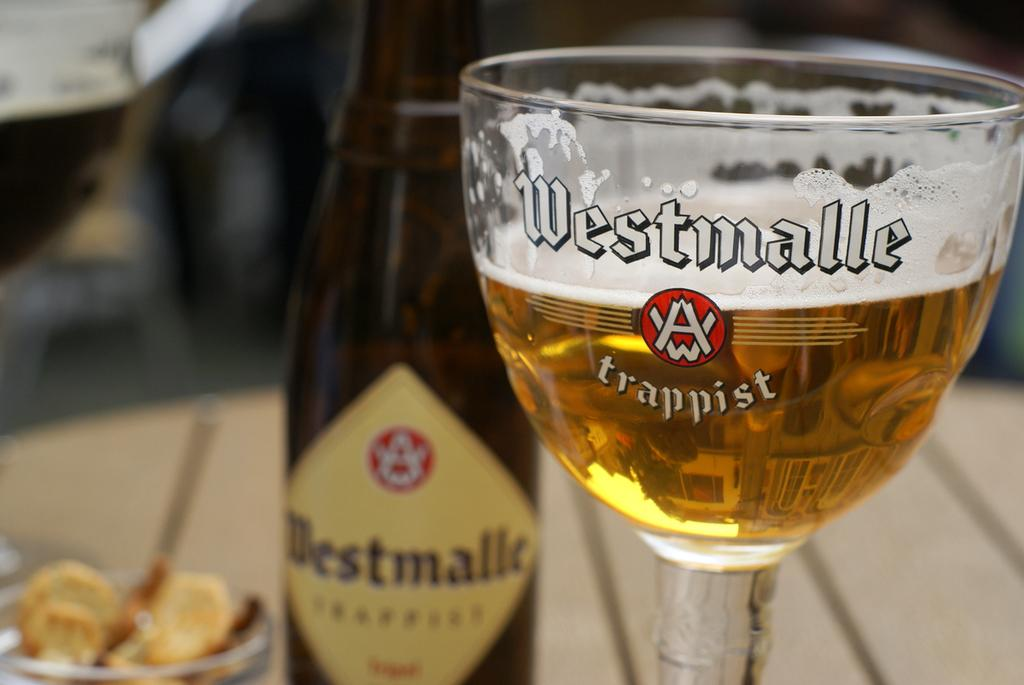What is present in the image that can hold a liquid? There is a glass in the image that can hold a liquid. What is written on the glass? "Westmalle" is written on the glass. What is inside the glass? There is a drink in the glass. What other container is present on the table? There is a glass bottle on the table. Can you see a ship sailing down a stream in the image? No, there is no ship or stream present in the image. 